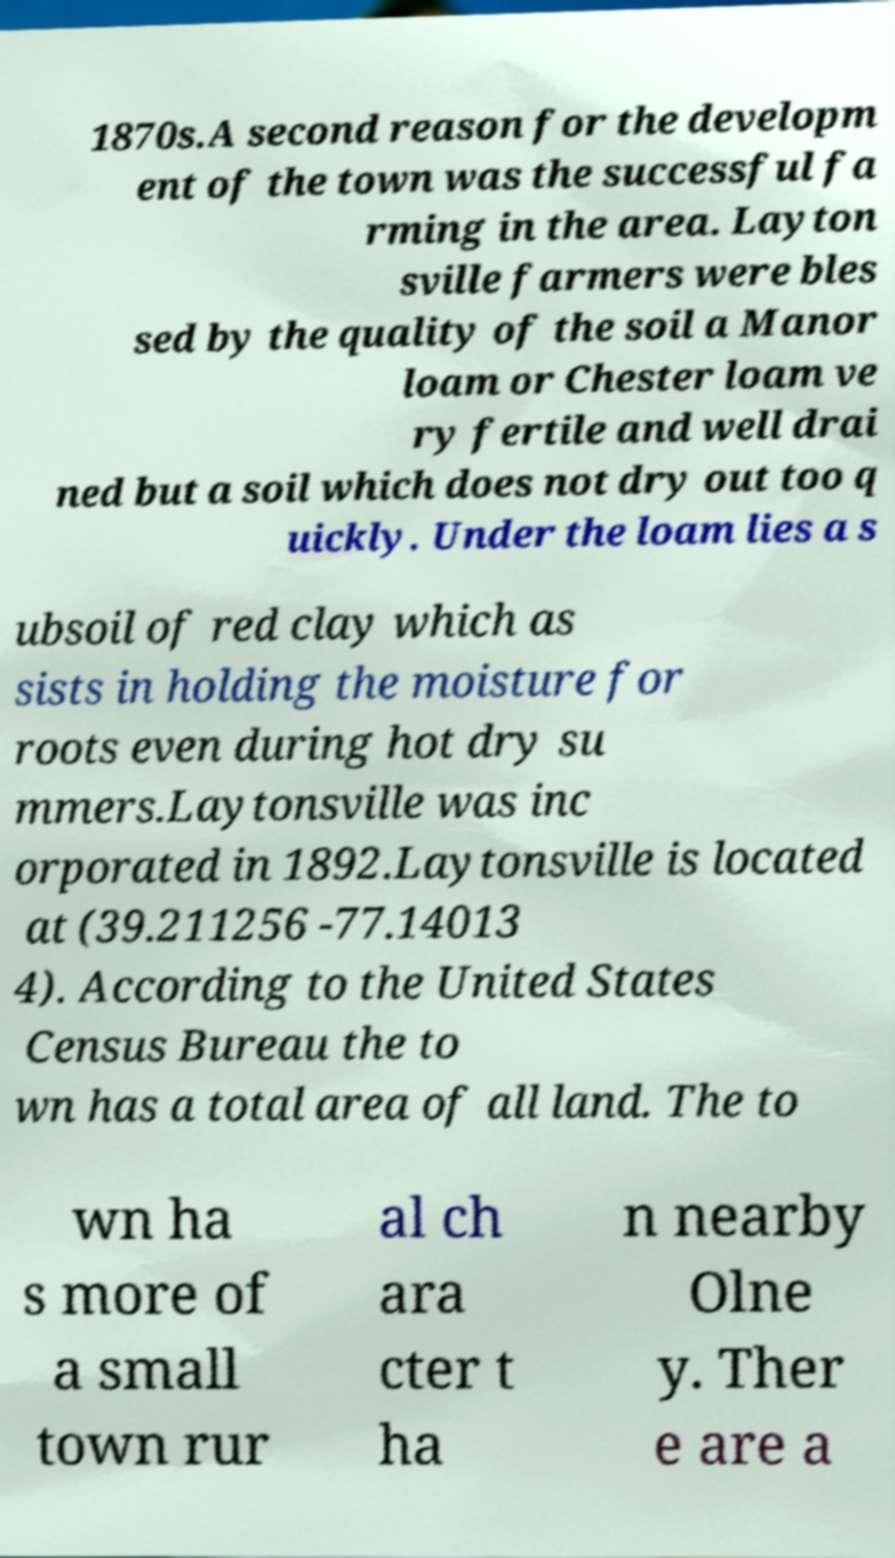Could you assist in decoding the text presented in this image and type it out clearly? 1870s.A second reason for the developm ent of the town was the successful fa rming in the area. Layton sville farmers were bles sed by the quality of the soil a Manor loam or Chester loam ve ry fertile and well drai ned but a soil which does not dry out too q uickly. Under the loam lies a s ubsoil of red clay which as sists in holding the moisture for roots even during hot dry su mmers.Laytonsville was inc orporated in 1892.Laytonsville is located at (39.211256 -77.14013 4). According to the United States Census Bureau the to wn has a total area of all land. The to wn ha s more of a small town rur al ch ara cter t ha n nearby Olne y. Ther e are a 